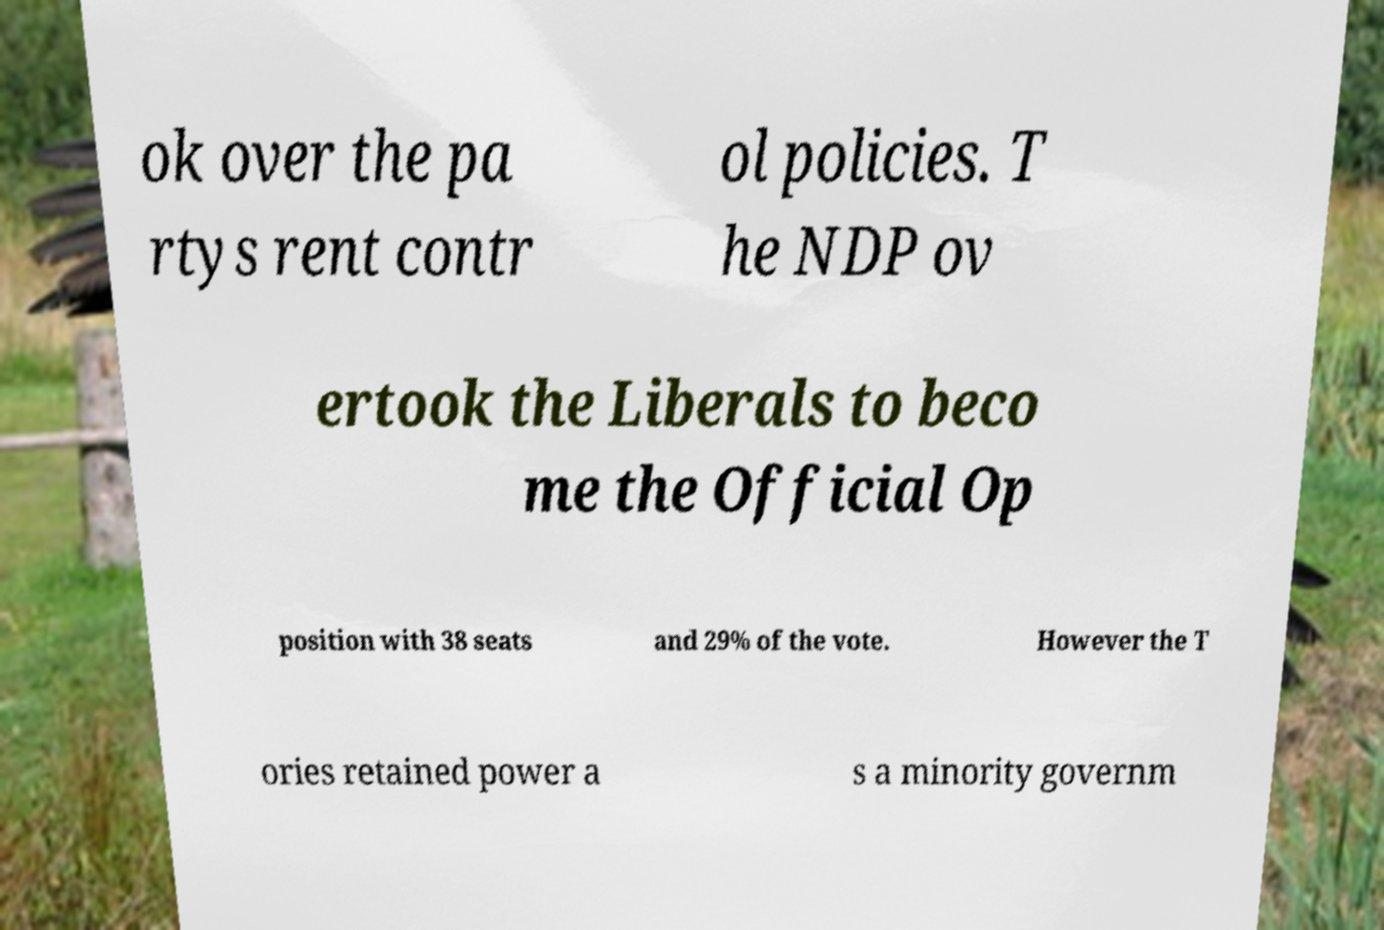What messages or text are displayed in this image? I need them in a readable, typed format. ok over the pa rtys rent contr ol policies. T he NDP ov ertook the Liberals to beco me the Official Op position with 38 seats and 29% of the vote. However the T ories retained power a s a minority governm 